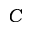Convert formula to latex. <formula><loc_0><loc_0><loc_500><loc_500>C</formula> 